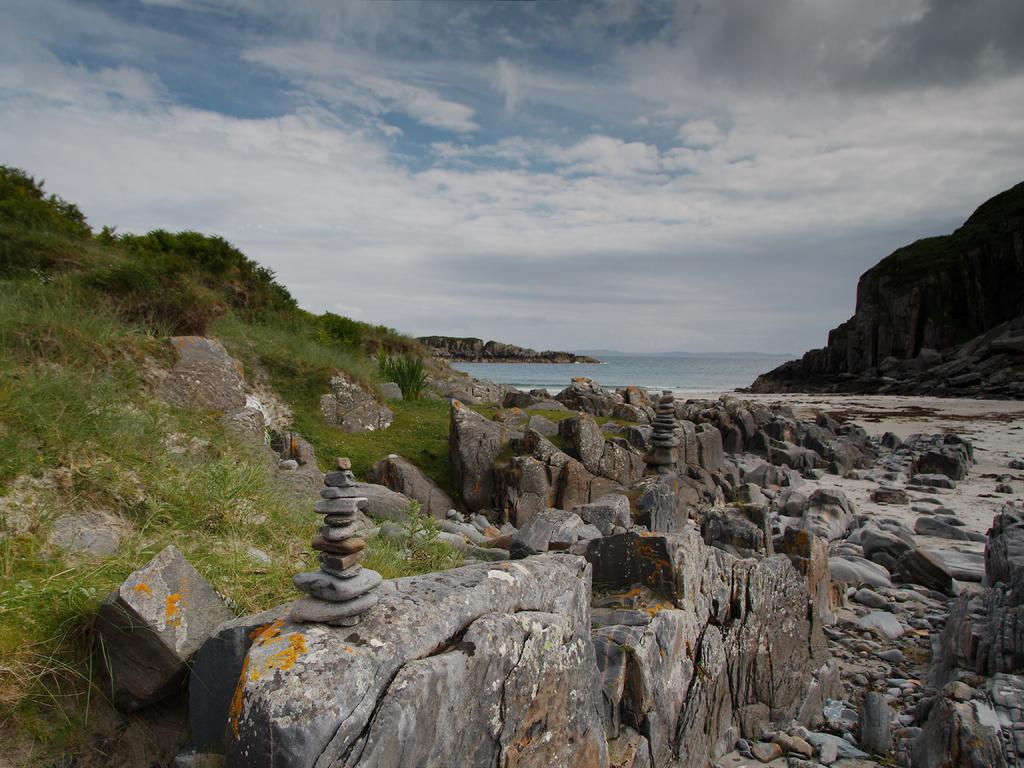What type of natural elements can be seen in the image? There are rocks, grass, and a water surface in the image. Are there any elevated landforms visible in the image? Yes, there are hills in the image. What type of steel structure can be seen in the image? There is no steel structure present in the image; it features natural elements such as rocks, grass, water surface, and hills. 